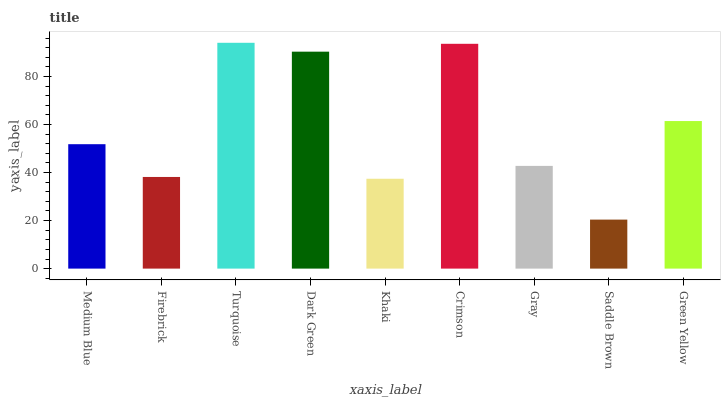Is Firebrick the minimum?
Answer yes or no. No. Is Firebrick the maximum?
Answer yes or no. No. Is Medium Blue greater than Firebrick?
Answer yes or no. Yes. Is Firebrick less than Medium Blue?
Answer yes or no. Yes. Is Firebrick greater than Medium Blue?
Answer yes or no. No. Is Medium Blue less than Firebrick?
Answer yes or no. No. Is Medium Blue the high median?
Answer yes or no. Yes. Is Medium Blue the low median?
Answer yes or no. Yes. Is Green Yellow the high median?
Answer yes or no. No. Is Gray the low median?
Answer yes or no. No. 